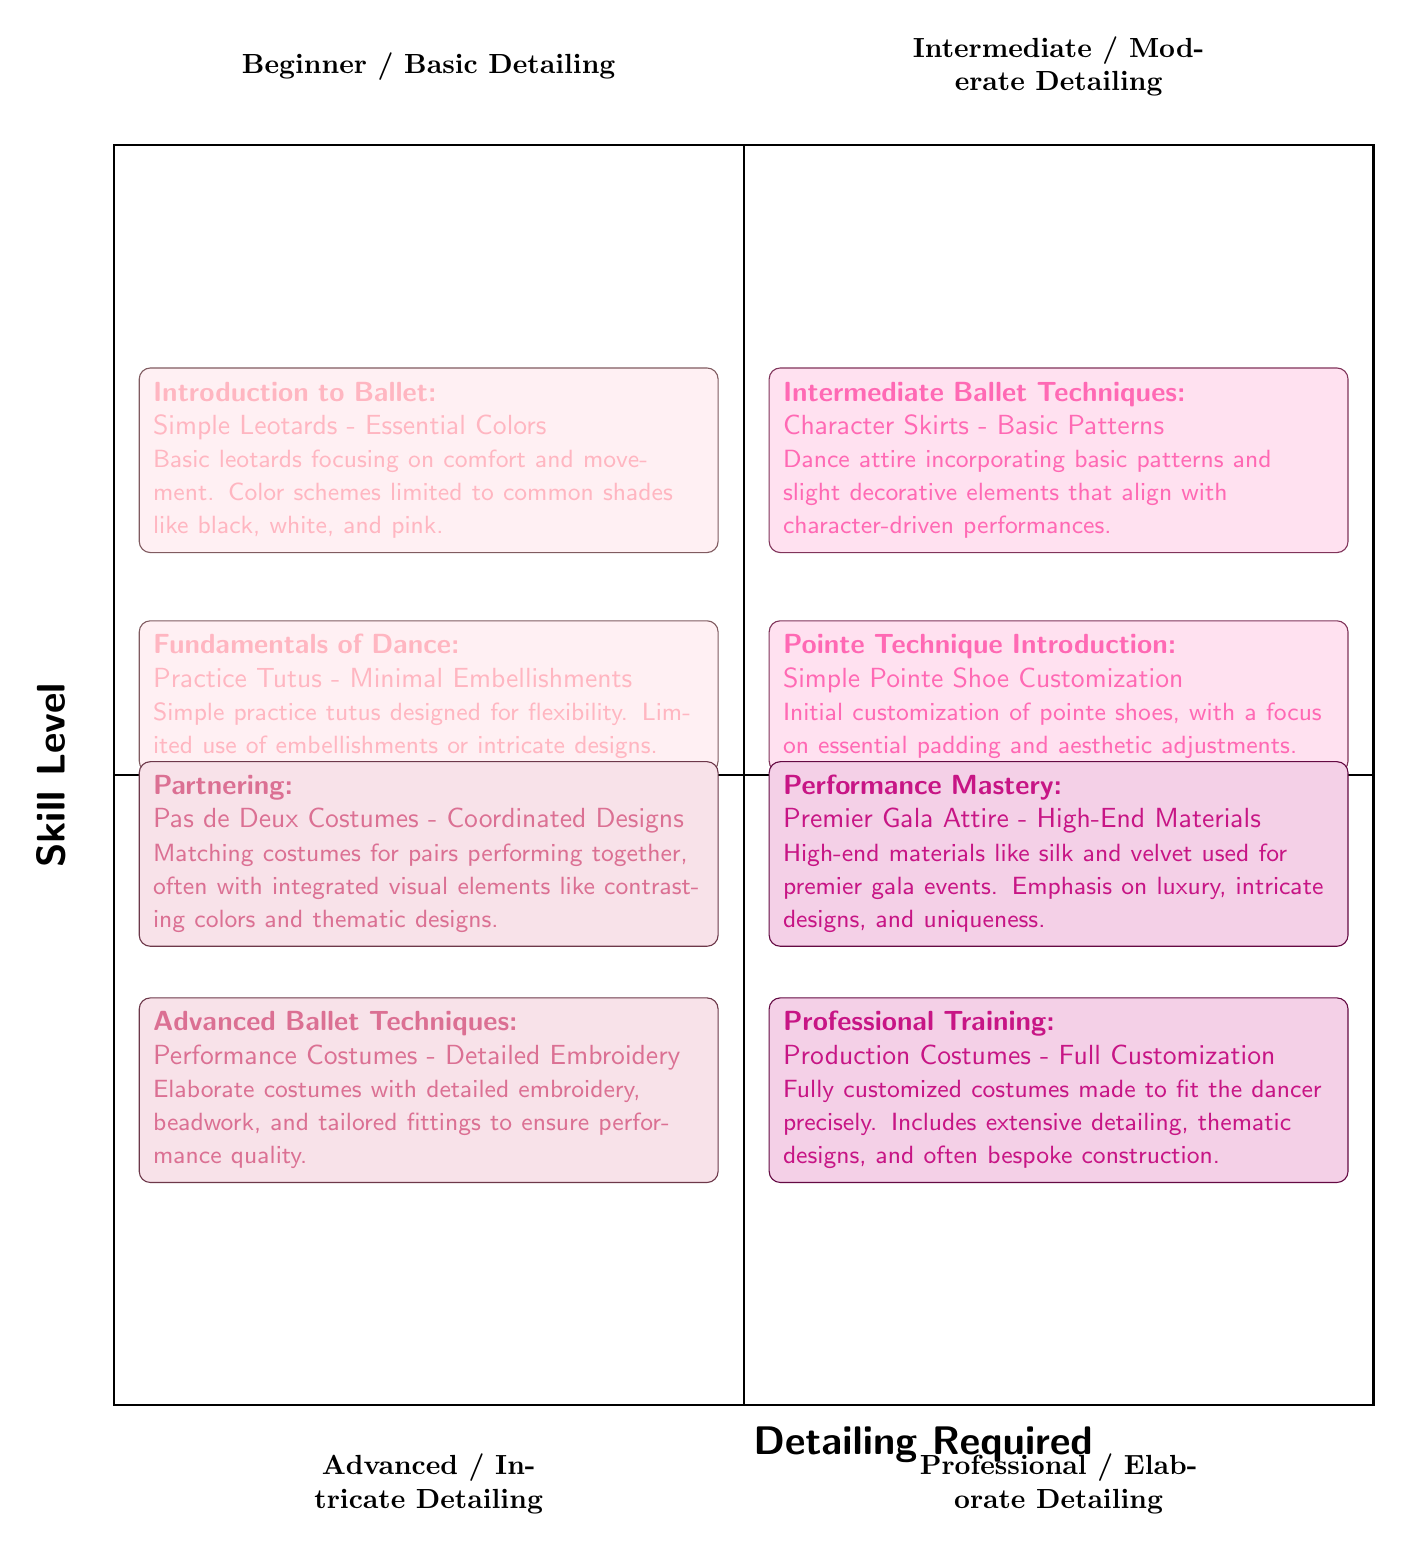What are the names of the quadrants in the diagram? The diagram contains four quadrants: Beginner / Basic Detailing, Intermediate / Moderate Detailing, Advanced / Intricate Detailing, and Professional / Elaborate Detailing. Each title is clearly labeled in its respective section of the quadrant chart.
Answer: Beginner / Basic Detailing, Intermediate / Moderate Detailing, Advanced / Intricate Detailing, Professional / Elaborate Detailing How many elements are in the "Professional / Elaborate Detailing" quadrant? The "Professional / Elaborate Detailing" quadrant has two elements listed: Production Costumes - Full Customization and Premier Gala Attire - High-End Materials. Each element represents a skill level and detailing requirements that pertain to professional dancers.
Answer: 2 What skill level corresponds to "Character Skirts - Basic Patterns"? The skill level that corresponds to "Character Skirts - Basic Patterns" is "Intermediate Ballet Techniques." This information is derived by checking the element listed under the Intermediate / Moderate Detailing quadrant.
Answer: Intermediate Ballet Techniques Which quadrant contains costumes that involve "Detailed Embroidery"? The quadrant that includes costumes with "Detailed Embroidery" is the Advanced / Intricate Detailing quadrant. This is indicated by the element titled "Performance Costumes - Detailed Embroidery," which specifically mentions detailed embroidery as a feature.
Answer: Advanced / Intricate Detailing What type of costume is associated with the "Pointe Technique Introduction"? The "Pointe Technique Introduction" is associated with "Simple Pointe Shoe Customization." This information can be found under the Intermediate / Moderate Detailing quadrant, where it describes an essential aspect of customization for pointe shoes.
Answer: Simple Pointe Shoe Customization What detailing requirement is needed for "Performance Mastery"? The detailing requirement for "Performance Mastery" is "Premier Gala Attire - High-End Materials." This requirement is specified in the Professional / Elaborate Detailing quadrant, detailing a focus on luxury and intricate designs for high-profile performances.
Answer: Premier Gala Attire - High-End Materials Which skill level requires costumes with "Matching designs for pairs performing together"? The skill level that requires "Matching designs for pairs performing together" is "Partnering." This element is found in the Advanced / Intricate Detailing quadrant and emphasizes the collaborative aspect of costume design for duo performances.
Answer: Partnering What is a common color theme for leotards in the "Beginner / Basic Detailing" quadrant? The common color theme for leotards specified in the "Beginner / Basic Detailing" quadrant is "Essential Colors," which includes black, white, and pink. This is described in the element detailing basic leotards that focus on comfort and movement.
Answer: Essential Colors 